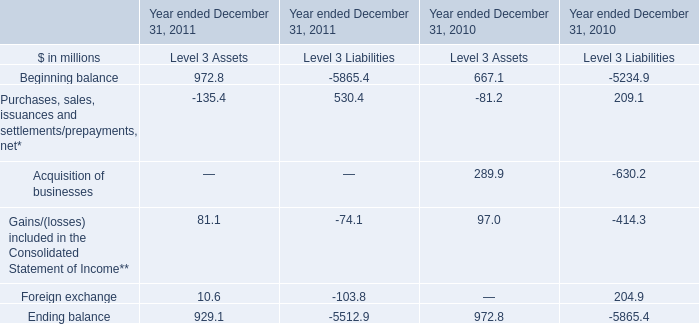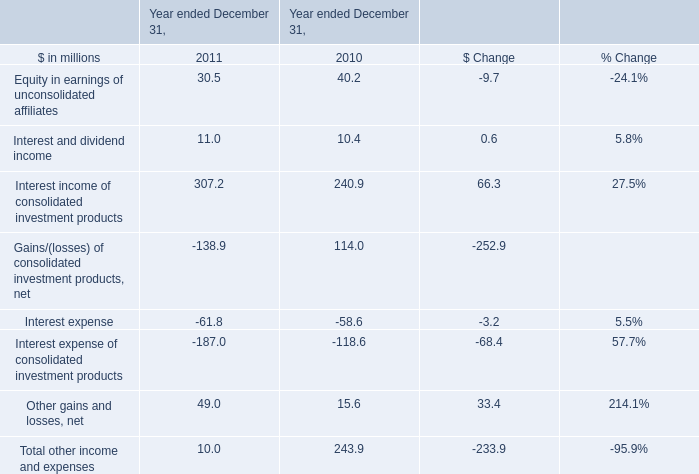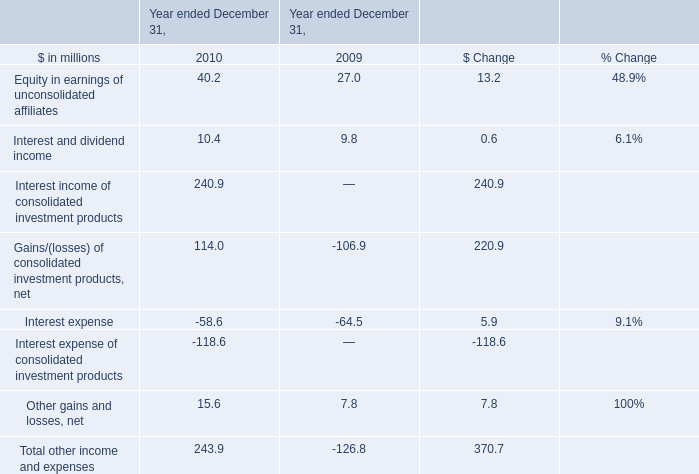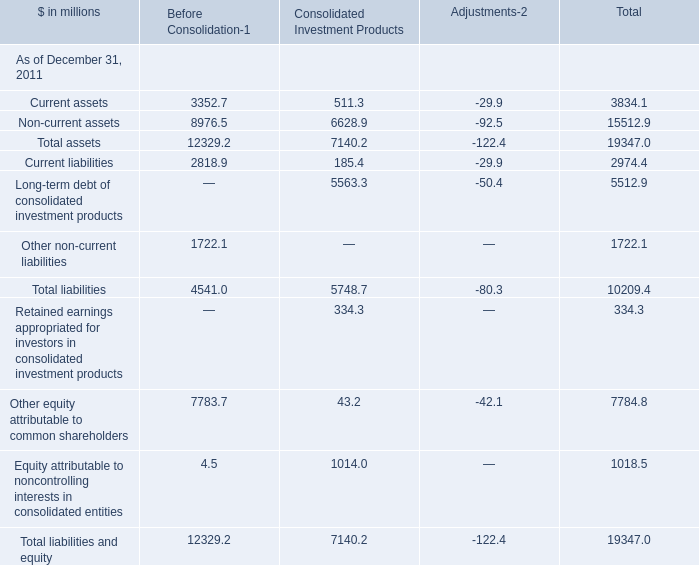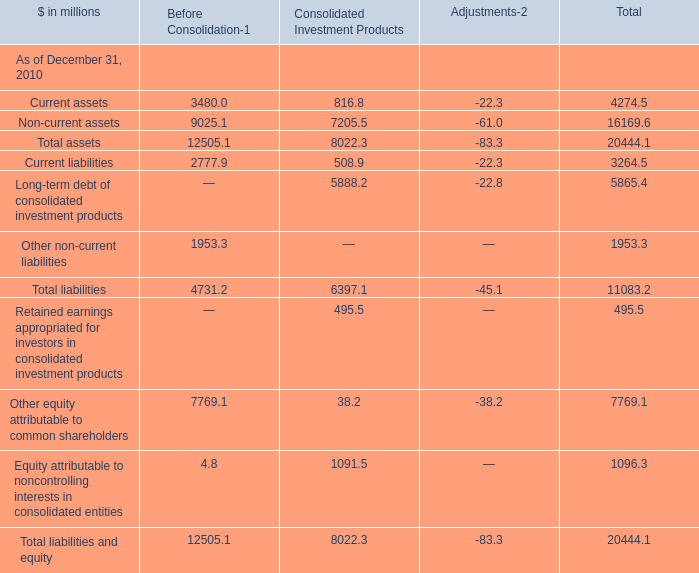What was the total amount of Current assets in the range of 1 and 4000 in 2011? (in million) 
Computations: (3352.7 + 511.3)
Answer: 3864.0. 